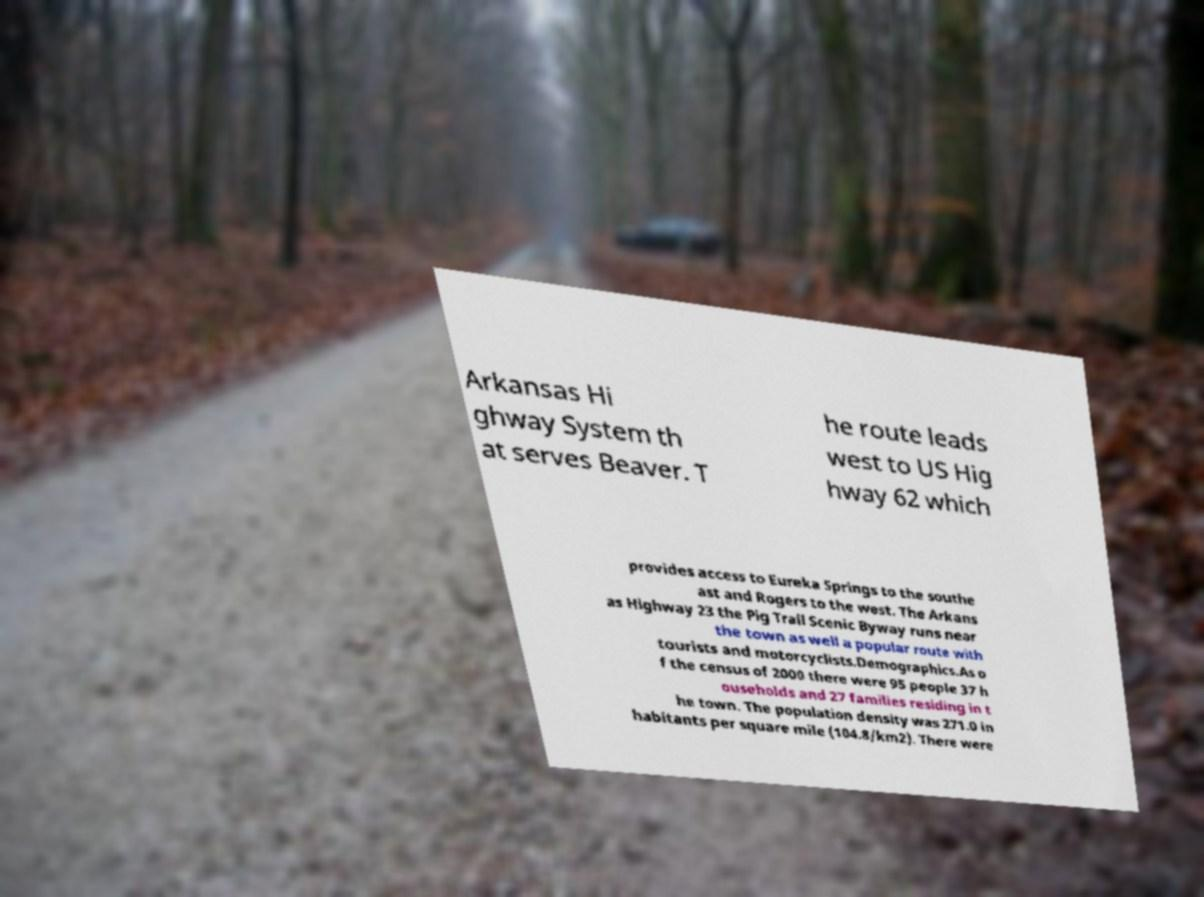What messages or text are displayed in this image? I need them in a readable, typed format. Arkansas Hi ghway System th at serves Beaver. T he route leads west to US Hig hway 62 which provides access to Eureka Springs to the southe ast and Rogers to the west. The Arkans as Highway 23 the Pig Trail Scenic Byway runs near the town as well a popular route with tourists and motorcyclists.Demographics.As o f the census of 2000 there were 95 people 37 h ouseholds and 27 families residing in t he town. The population density was 271.0 in habitants per square mile (104.8/km2). There were 